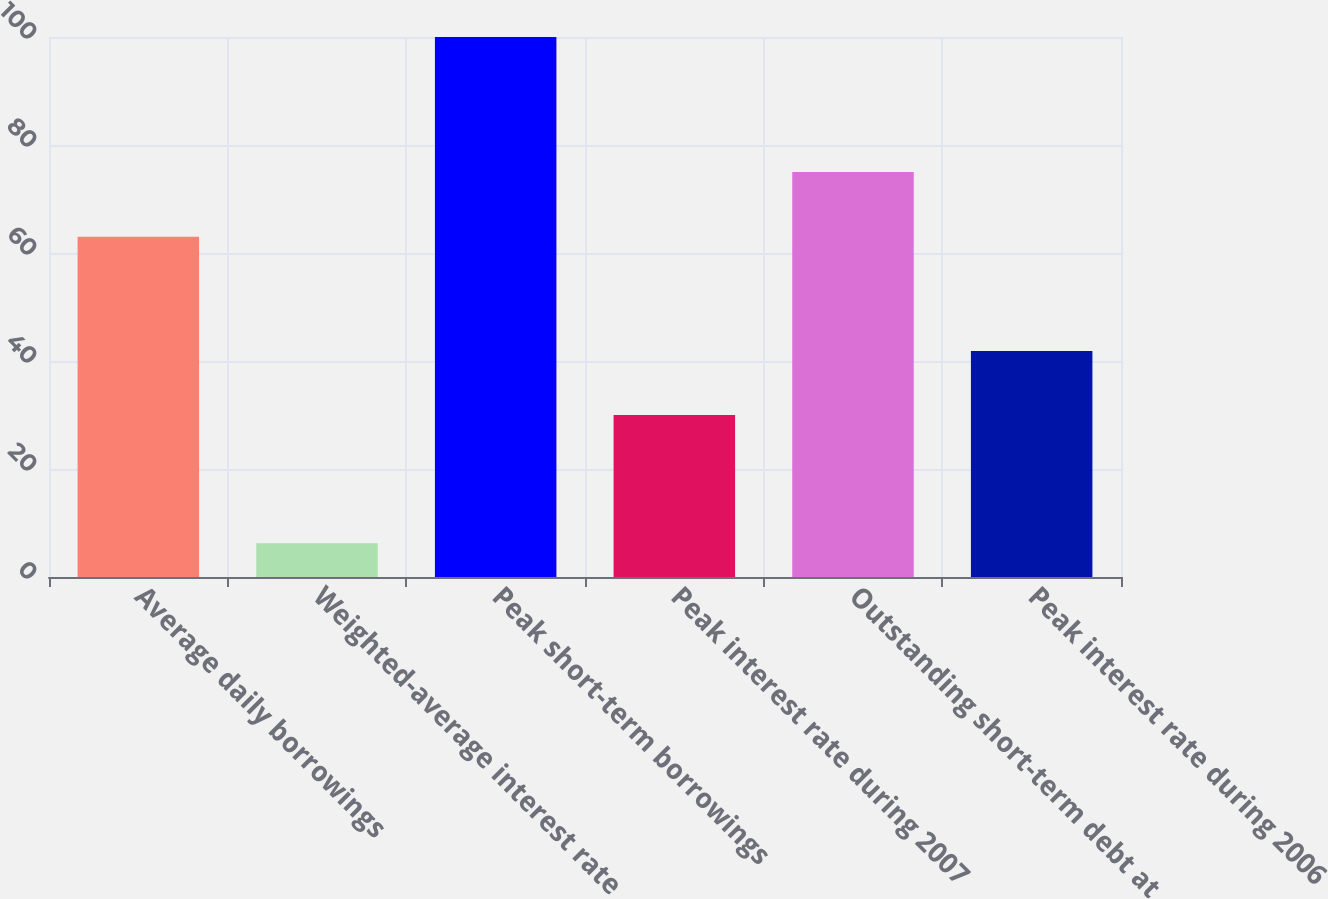<chart> <loc_0><loc_0><loc_500><loc_500><bar_chart><fcel>Average daily borrowings<fcel>Weighted-average interest rate<fcel>Peak short-term borrowings<fcel>Peak interest rate during 2007<fcel>Outstanding short-term debt at<fcel>Peak interest rate during 2006<nl><fcel>63<fcel>6.23<fcel>100<fcel>29.99<fcel>75<fcel>41.87<nl></chart> 